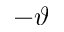<formula> <loc_0><loc_0><loc_500><loc_500>- \vartheta</formula> 